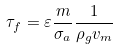Convert formula to latex. <formula><loc_0><loc_0><loc_500><loc_500>\tau _ { f } = \varepsilon \frac { m } { \sigma _ { a } } \frac { 1 } { \rho _ { g } v _ { m } }</formula> 